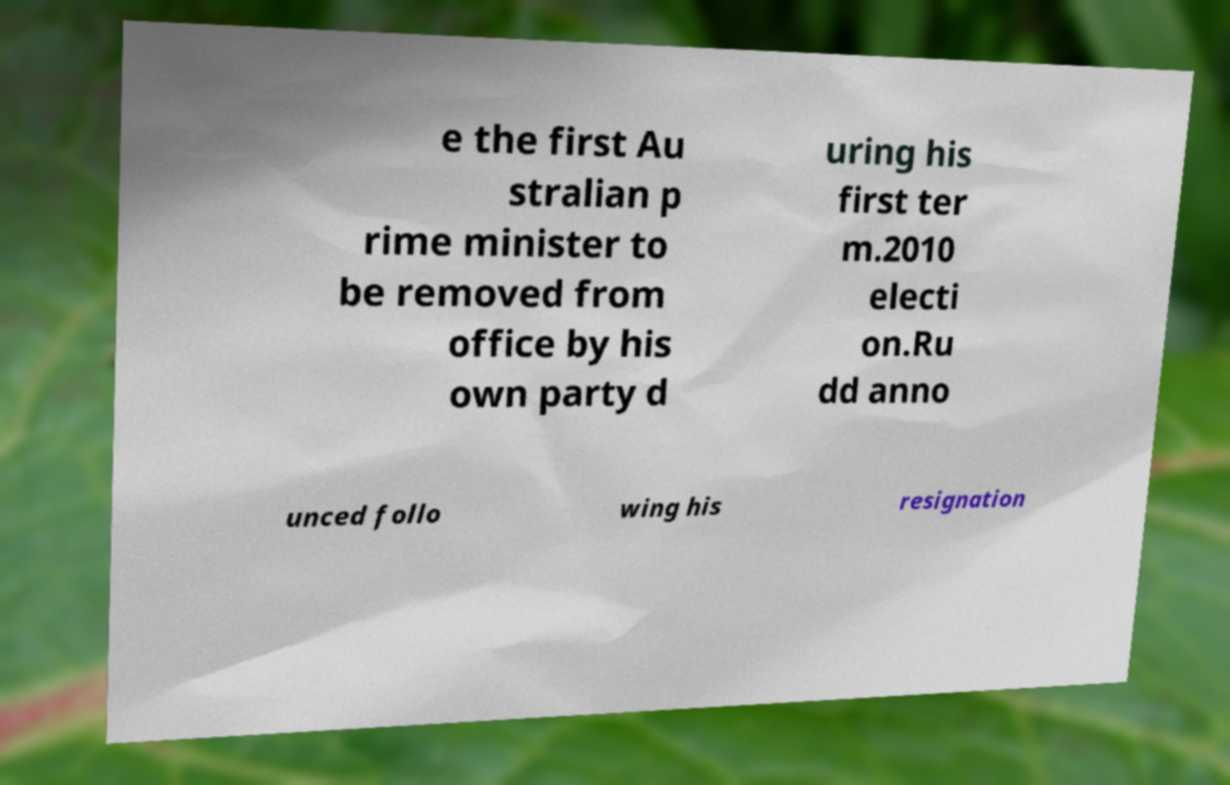Can you read and provide the text displayed in the image?This photo seems to have some interesting text. Can you extract and type it out for me? e the first Au stralian p rime minister to be removed from office by his own party d uring his first ter m.2010 electi on.Ru dd anno unced follo wing his resignation 